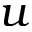<formula> <loc_0><loc_0><loc_500><loc_500>u</formula> 